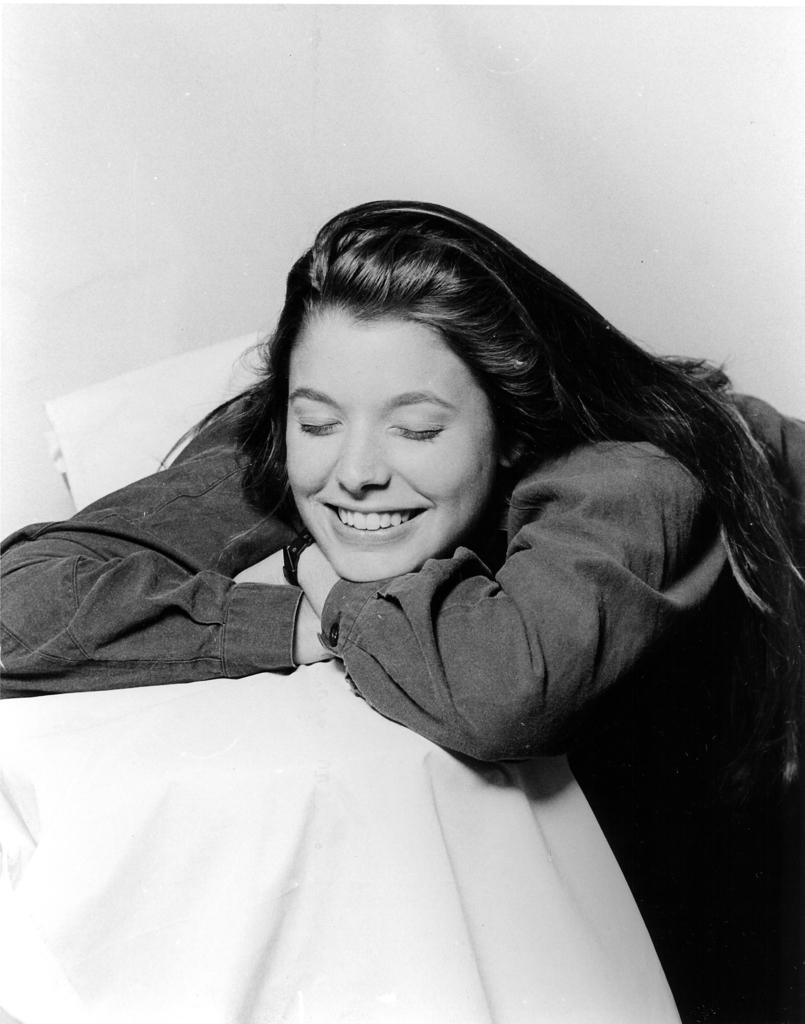How would you summarize this image in a sentence or two? It is the black and white image in which there is a girl laying on the table by keeping her hands on it. 